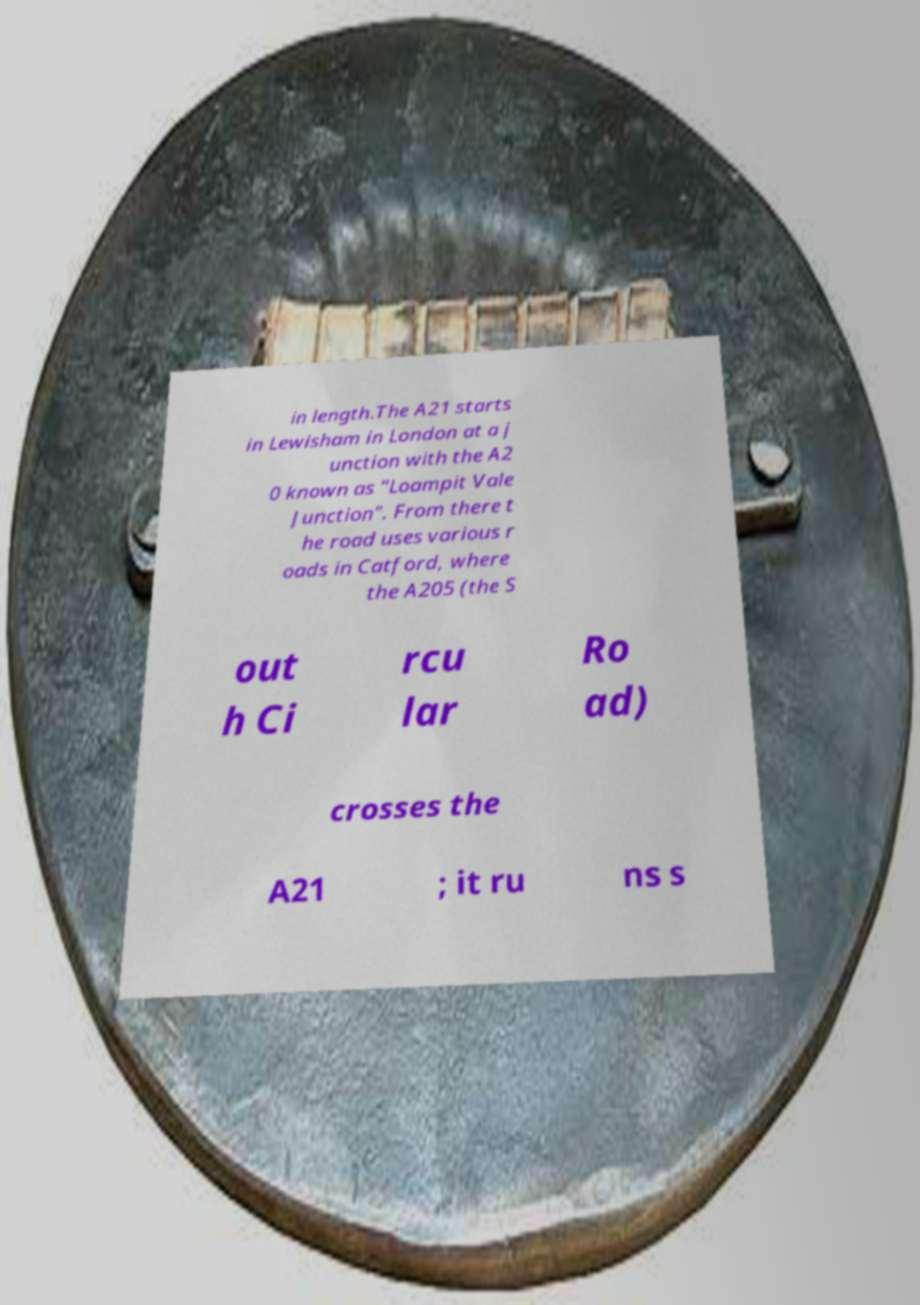There's text embedded in this image that I need extracted. Can you transcribe it verbatim? in length.The A21 starts in Lewisham in London at a j unction with the A2 0 known as "Loampit Vale Junction". From there t he road uses various r oads in Catford, where the A205 (the S out h Ci rcu lar Ro ad) crosses the A21 ; it ru ns s 